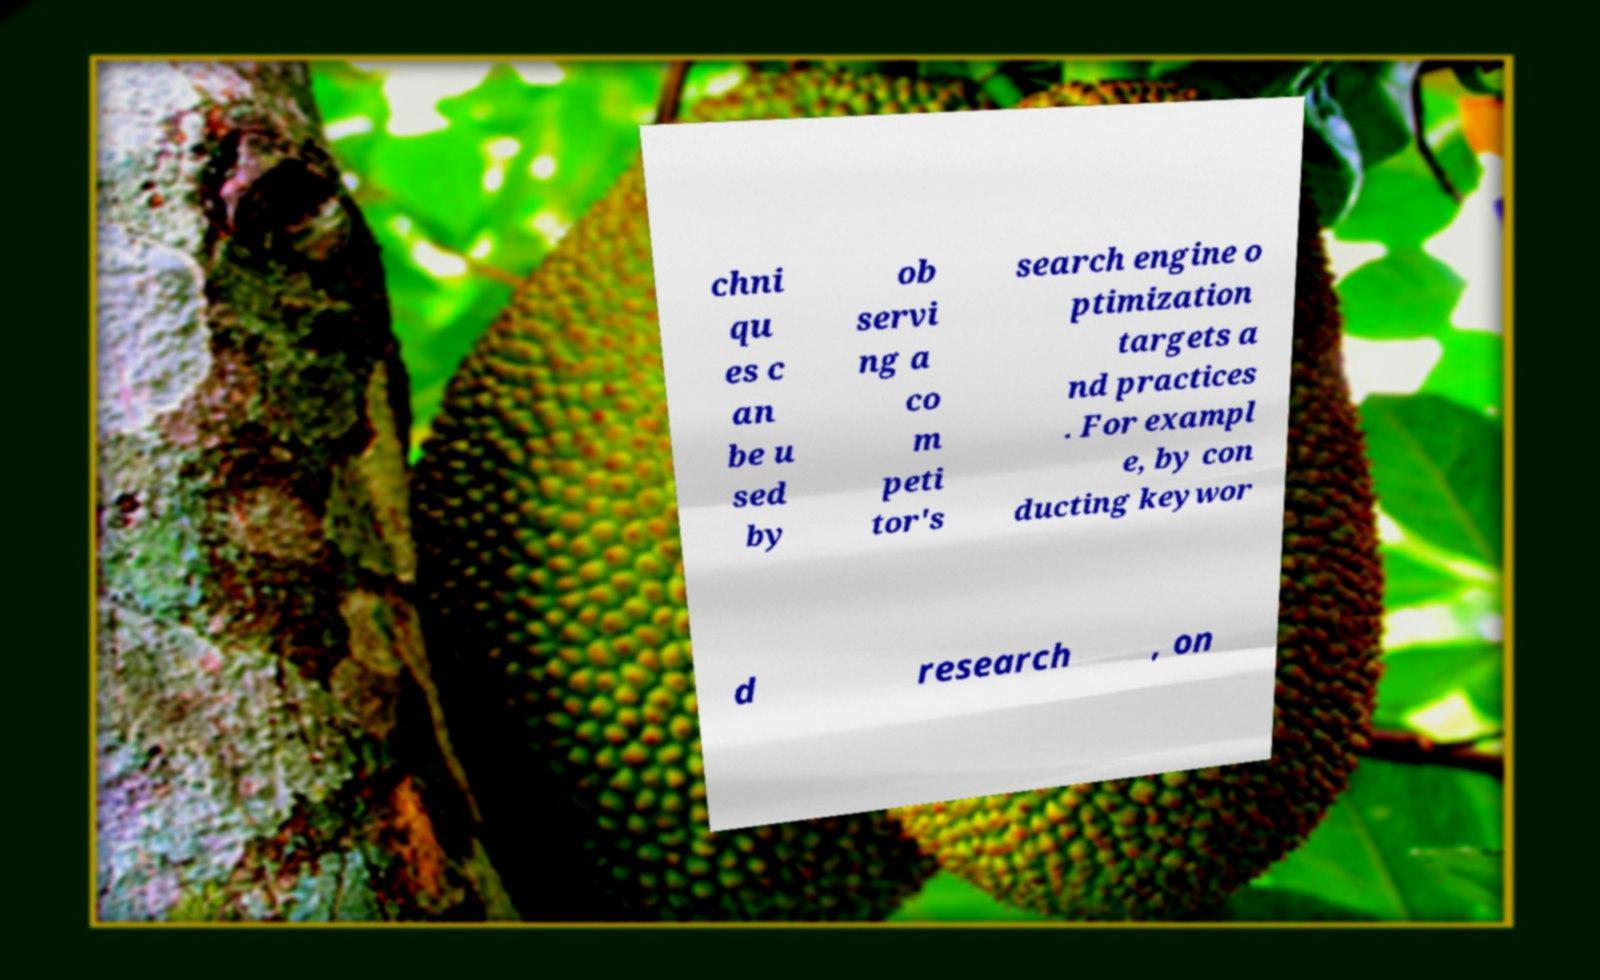Please identify and transcribe the text found in this image. chni qu es c an be u sed by ob servi ng a co m peti tor's search engine o ptimization targets a nd practices . For exampl e, by con ducting keywor d research , on 